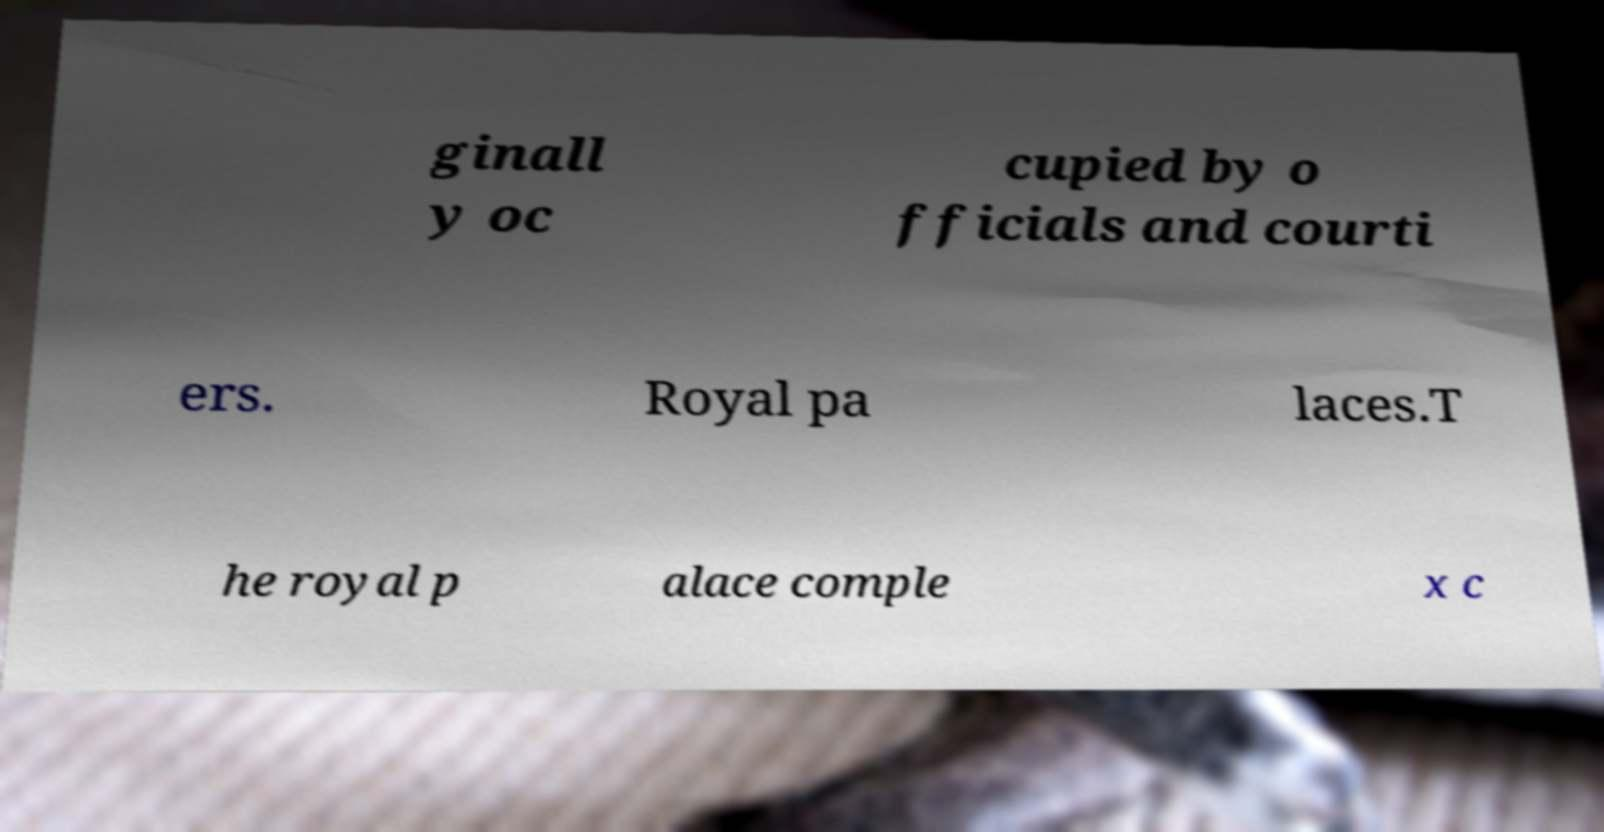Please identify and transcribe the text found in this image. ginall y oc cupied by o fficials and courti ers. Royal pa laces.T he royal p alace comple x c 